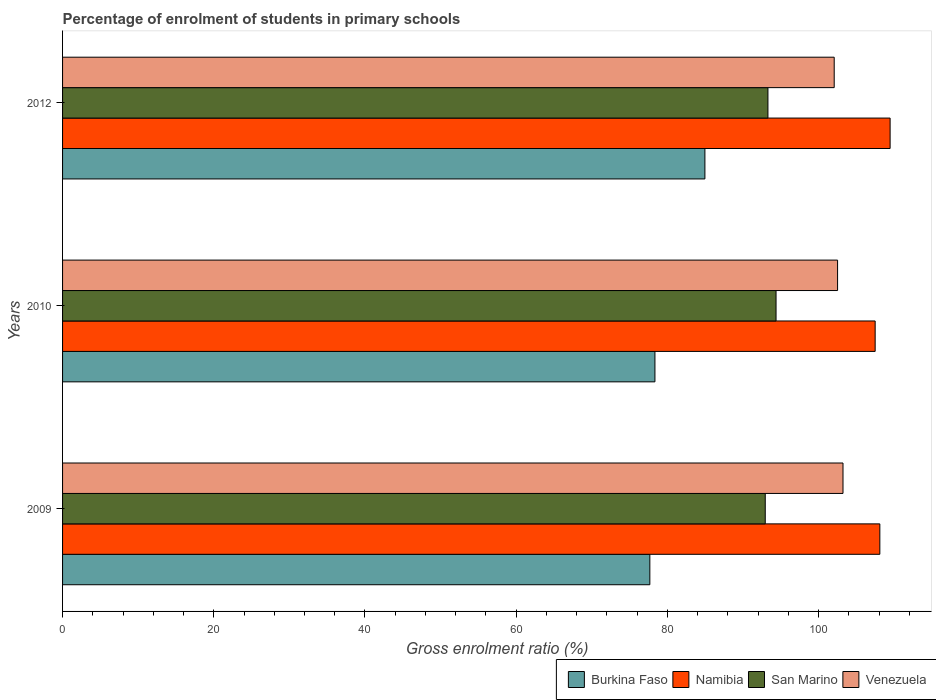How many different coloured bars are there?
Provide a succinct answer. 4. Are the number of bars per tick equal to the number of legend labels?
Give a very brief answer. Yes. What is the label of the 3rd group of bars from the top?
Offer a very short reply. 2009. In how many cases, is the number of bars for a given year not equal to the number of legend labels?
Offer a very short reply. 0. What is the percentage of students enrolled in primary schools in Venezuela in 2012?
Keep it short and to the point. 102.07. Across all years, what is the maximum percentage of students enrolled in primary schools in Venezuela?
Ensure brevity in your answer.  103.23. Across all years, what is the minimum percentage of students enrolled in primary schools in Namibia?
Ensure brevity in your answer.  107.48. In which year was the percentage of students enrolled in primary schools in Namibia minimum?
Give a very brief answer. 2010. What is the total percentage of students enrolled in primary schools in Namibia in the graph?
Provide a succinct answer. 325.05. What is the difference between the percentage of students enrolled in primary schools in Namibia in 2009 and that in 2012?
Your answer should be very brief. -1.36. What is the difference between the percentage of students enrolled in primary schools in Venezuela in 2010 and the percentage of students enrolled in primary schools in Burkina Faso in 2009?
Offer a terse response. 24.83. What is the average percentage of students enrolled in primary schools in Burkina Faso per year?
Offer a terse response. 80.33. In the year 2012, what is the difference between the percentage of students enrolled in primary schools in Namibia and percentage of students enrolled in primary schools in Venezuela?
Provide a short and direct response. 7.39. What is the ratio of the percentage of students enrolled in primary schools in San Marino in 2009 to that in 2012?
Your response must be concise. 1. Is the difference between the percentage of students enrolled in primary schools in Namibia in 2010 and 2012 greater than the difference between the percentage of students enrolled in primary schools in Venezuela in 2010 and 2012?
Offer a terse response. No. What is the difference between the highest and the second highest percentage of students enrolled in primary schools in Venezuela?
Keep it short and to the point. 0.72. What is the difference between the highest and the lowest percentage of students enrolled in primary schools in Venezuela?
Ensure brevity in your answer.  1.16. Is the sum of the percentage of students enrolled in primary schools in Venezuela in 2010 and 2012 greater than the maximum percentage of students enrolled in primary schools in San Marino across all years?
Your response must be concise. Yes. What does the 1st bar from the top in 2010 represents?
Your response must be concise. Venezuela. What does the 1st bar from the bottom in 2009 represents?
Your answer should be compact. Burkina Faso. Is it the case that in every year, the sum of the percentage of students enrolled in primary schools in Namibia and percentage of students enrolled in primary schools in Burkina Faso is greater than the percentage of students enrolled in primary schools in San Marino?
Ensure brevity in your answer.  Yes. Are all the bars in the graph horizontal?
Keep it short and to the point. Yes. How many years are there in the graph?
Keep it short and to the point. 3. Are the values on the major ticks of X-axis written in scientific E-notation?
Give a very brief answer. No. Does the graph contain grids?
Make the answer very short. No. Where does the legend appear in the graph?
Your answer should be compact. Bottom right. How many legend labels are there?
Provide a short and direct response. 4. How are the legend labels stacked?
Provide a short and direct response. Horizontal. What is the title of the graph?
Provide a succinct answer. Percentage of enrolment of students in primary schools. Does "Swaziland" appear as one of the legend labels in the graph?
Ensure brevity in your answer.  No. What is the label or title of the X-axis?
Your response must be concise. Gross enrolment ratio (%). What is the label or title of the Y-axis?
Offer a terse response. Years. What is the Gross enrolment ratio (%) in Burkina Faso in 2009?
Offer a terse response. 77.68. What is the Gross enrolment ratio (%) in Namibia in 2009?
Your answer should be compact. 108.1. What is the Gross enrolment ratio (%) in San Marino in 2009?
Your answer should be compact. 92.95. What is the Gross enrolment ratio (%) in Venezuela in 2009?
Offer a very short reply. 103.23. What is the Gross enrolment ratio (%) in Burkina Faso in 2010?
Your response must be concise. 78.36. What is the Gross enrolment ratio (%) in Namibia in 2010?
Your answer should be very brief. 107.48. What is the Gross enrolment ratio (%) of San Marino in 2010?
Provide a short and direct response. 94.37. What is the Gross enrolment ratio (%) of Venezuela in 2010?
Offer a very short reply. 102.51. What is the Gross enrolment ratio (%) of Burkina Faso in 2012?
Your answer should be compact. 84.96. What is the Gross enrolment ratio (%) of Namibia in 2012?
Provide a succinct answer. 109.46. What is the Gross enrolment ratio (%) in San Marino in 2012?
Offer a terse response. 93.3. What is the Gross enrolment ratio (%) in Venezuela in 2012?
Provide a succinct answer. 102.07. Across all years, what is the maximum Gross enrolment ratio (%) in Burkina Faso?
Your response must be concise. 84.96. Across all years, what is the maximum Gross enrolment ratio (%) in Namibia?
Make the answer very short. 109.46. Across all years, what is the maximum Gross enrolment ratio (%) of San Marino?
Give a very brief answer. 94.37. Across all years, what is the maximum Gross enrolment ratio (%) of Venezuela?
Make the answer very short. 103.23. Across all years, what is the minimum Gross enrolment ratio (%) in Burkina Faso?
Give a very brief answer. 77.68. Across all years, what is the minimum Gross enrolment ratio (%) in Namibia?
Give a very brief answer. 107.48. Across all years, what is the minimum Gross enrolment ratio (%) in San Marino?
Keep it short and to the point. 92.95. Across all years, what is the minimum Gross enrolment ratio (%) in Venezuela?
Your answer should be very brief. 102.07. What is the total Gross enrolment ratio (%) of Burkina Faso in the graph?
Your answer should be compact. 241. What is the total Gross enrolment ratio (%) in Namibia in the graph?
Give a very brief answer. 325.05. What is the total Gross enrolment ratio (%) of San Marino in the graph?
Provide a succinct answer. 280.62. What is the total Gross enrolment ratio (%) in Venezuela in the graph?
Provide a short and direct response. 307.81. What is the difference between the Gross enrolment ratio (%) in Burkina Faso in 2009 and that in 2010?
Offer a very short reply. -0.67. What is the difference between the Gross enrolment ratio (%) in Namibia in 2009 and that in 2010?
Offer a very short reply. 0.62. What is the difference between the Gross enrolment ratio (%) of San Marino in 2009 and that in 2010?
Your answer should be compact. -1.43. What is the difference between the Gross enrolment ratio (%) of Venezuela in 2009 and that in 2010?
Your answer should be very brief. 0.72. What is the difference between the Gross enrolment ratio (%) in Burkina Faso in 2009 and that in 2012?
Offer a very short reply. -7.28. What is the difference between the Gross enrolment ratio (%) in Namibia in 2009 and that in 2012?
Your response must be concise. -1.36. What is the difference between the Gross enrolment ratio (%) in San Marino in 2009 and that in 2012?
Provide a short and direct response. -0.36. What is the difference between the Gross enrolment ratio (%) of Venezuela in 2009 and that in 2012?
Offer a very short reply. 1.16. What is the difference between the Gross enrolment ratio (%) of Burkina Faso in 2010 and that in 2012?
Ensure brevity in your answer.  -6.61. What is the difference between the Gross enrolment ratio (%) of Namibia in 2010 and that in 2012?
Offer a very short reply. -1.98. What is the difference between the Gross enrolment ratio (%) of San Marino in 2010 and that in 2012?
Give a very brief answer. 1.07. What is the difference between the Gross enrolment ratio (%) in Venezuela in 2010 and that in 2012?
Keep it short and to the point. 0.45. What is the difference between the Gross enrolment ratio (%) in Burkina Faso in 2009 and the Gross enrolment ratio (%) in Namibia in 2010?
Your answer should be compact. -29.8. What is the difference between the Gross enrolment ratio (%) of Burkina Faso in 2009 and the Gross enrolment ratio (%) of San Marino in 2010?
Offer a very short reply. -16.69. What is the difference between the Gross enrolment ratio (%) of Burkina Faso in 2009 and the Gross enrolment ratio (%) of Venezuela in 2010?
Your answer should be compact. -24.83. What is the difference between the Gross enrolment ratio (%) of Namibia in 2009 and the Gross enrolment ratio (%) of San Marino in 2010?
Keep it short and to the point. 13.73. What is the difference between the Gross enrolment ratio (%) of Namibia in 2009 and the Gross enrolment ratio (%) of Venezuela in 2010?
Provide a succinct answer. 5.59. What is the difference between the Gross enrolment ratio (%) of San Marino in 2009 and the Gross enrolment ratio (%) of Venezuela in 2010?
Provide a short and direct response. -9.57. What is the difference between the Gross enrolment ratio (%) in Burkina Faso in 2009 and the Gross enrolment ratio (%) in Namibia in 2012?
Your answer should be very brief. -31.78. What is the difference between the Gross enrolment ratio (%) in Burkina Faso in 2009 and the Gross enrolment ratio (%) in San Marino in 2012?
Your answer should be compact. -15.62. What is the difference between the Gross enrolment ratio (%) in Burkina Faso in 2009 and the Gross enrolment ratio (%) in Venezuela in 2012?
Make the answer very short. -24.39. What is the difference between the Gross enrolment ratio (%) of Namibia in 2009 and the Gross enrolment ratio (%) of San Marino in 2012?
Your answer should be very brief. 14.8. What is the difference between the Gross enrolment ratio (%) of Namibia in 2009 and the Gross enrolment ratio (%) of Venezuela in 2012?
Offer a terse response. 6.04. What is the difference between the Gross enrolment ratio (%) in San Marino in 2009 and the Gross enrolment ratio (%) in Venezuela in 2012?
Keep it short and to the point. -9.12. What is the difference between the Gross enrolment ratio (%) in Burkina Faso in 2010 and the Gross enrolment ratio (%) in Namibia in 2012?
Offer a very short reply. -31.11. What is the difference between the Gross enrolment ratio (%) of Burkina Faso in 2010 and the Gross enrolment ratio (%) of San Marino in 2012?
Offer a terse response. -14.95. What is the difference between the Gross enrolment ratio (%) in Burkina Faso in 2010 and the Gross enrolment ratio (%) in Venezuela in 2012?
Give a very brief answer. -23.71. What is the difference between the Gross enrolment ratio (%) in Namibia in 2010 and the Gross enrolment ratio (%) in San Marino in 2012?
Your response must be concise. 14.18. What is the difference between the Gross enrolment ratio (%) of Namibia in 2010 and the Gross enrolment ratio (%) of Venezuela in 2012?
Provide a short and direct response. 5.42. What is the difference between the Gross enrolment ratio (%) in San Marino in 2010 and the Gross enrolment ratio (%) in Venezuela in 2012?
Provide a succinct answer. -7.69. What is the average Gross enrolment ratio (%) of Burkina Faso per year?
Your response must be concise. 80.33. What is the average Gross enrolment ratio (%) of Namibia per year?
Make the answer very short. 108.35. What is the average Gross enrolment ratio (%) in San Marino per year?
Offer a very short reply. 93.54. What is the average Gross enrolment ratio (%) in Venezuela per year?
Provide a succinct answer. 102.6. In the year 2009, what is the difference between the Gross enrolment ratio (%) of Burkina Faso and Gross enrolment ratio (%) of Namibia?
Make the answer very short. -30.42. In the year 2009, what is the difference between the Gross enrolment ratio (%) in Burkina Faso and Gross enrolment ratio (%) in San Marino?
Provide a succinct answer. -15.27. In the year 2009, what is the difference between the Gross enrolment ratio (%) of Burkina Faso and Gross enrolment ratio (%) of Venezuela?
Ensure brevity in your answer.  -25.55. In the year 2009, what is the difference between the Gross enrolment ratio (%) of Namibia and Gross enrolment ratio (%) of San Marino?
Provide a short and direct response. 15.16. In the year 2009, what is the difference between the Gross enrolment ratio (%) of Namibia and Gross enrolment ratio (%) of Venezuela?
Offer a very short reply. 4.87. In the year 2009, what is the difference between the Gross enrolment ratio (%) in San Marino and Gross enrolment ratio (%) in Venezuela?
Give a very brief answer. -10.29. In the year 2010, what is the difference between the Gross enrolment ratio (%) in Burkina Faso and Gross enrolment ratio (%) in Namibia?
Provide a short and direct response. -29.13. In the year 2010, what is the difference between the Gross enrolment ratio (%) of Burkina Faso and Gross enrolment ratio (%) of San Marino?
Provide a succinct answer. -16.02. In the year 2010, what is the difference between the Gross enrolment ratio (%) in Burkina Faso and Gross enrolment ratio (%) in Venezuela?
Keep it short and to the point. -24.16. In the year 2010, what is the difference between the Gross enrolment ratio (%) in Namibia and Gross enrolment ratio (%) in San Marino?
Provide a succinct answer. 13.11. In the year 2010, what is the difference between the Gross enrolment ratio (%) in Namibia and Gross enrolment ratio (%) in Venezuela?
Provide a succinct answer. 4.97. In the year 2010, what is the difference between the Gross enrolment ratio (%) of San Marino and Gross enrolment ratio (%) of Venezuela?
Give a very brief answer. -8.14. In the year 2012, what is the difference between the Gross enrolment ratio (%) in Burkina Faso and Gross enrolment ratio (%) in Namibia?
Keep it short and to the point. -24.5. In the year 2012, what is the difference between the Gross enrolment ratio (%) in Burkina Faso and Gross enrolment ratio (%) in San Marino?
Offer a very short reply. -8.34. In the year 2012, what is the difference between the Gross enrolment ratio (%) of Burkina Faso and Gross enrolment ratio (%) of Venezuela?
Keep it short and to the point. -17.1. In the year 2012, what is the difference between the Gross enrolment ratio (%) of Namibia and Gross enrolment ratio (%) of San Marino?
Give a very brief answer. 16.16. In the year 2012, what is the difference between the Gross enrolment ratio (%) in Namibia and Gross enrolment ratio (%) in Venezuela?
Offer a very short reply. 7.39. In the year 2012, what is the difference between the Gross enrolment ratio (%) in San Marino and Gross enrolment ratio (%) in Venezuela?
Give a very brief answer. -8.77. What is the ratio of the Gross enrolment ratio (%) of Burkina Faso in 2009 to that in 2010?
Provide a succinct answer. 0.99. What is the ratio of the Gross enrolment ratio (%) of Namibia in 2009 to that in 2010?
Your answer should be compact. 1.01. What is the ratio of the Gross enrolment ratio (%) in San Marino in 2009 to that in 2010?
Provide a short and direct response. 0.98. What is the ratio of the Gross enrolment ratio (%) in Burkina Faso in 2009 to that in 2012?
Your answer should be compact. 0.91. What is the ratio of the Gross enrolment ratio (%) of Namibia in 2009 to that in 2012?
Your response must be concise. 0.99. What is the ratio of the Gross enrolment ratio (%) of Venezuela in 2009 to that in 2012?
Offer a very short reply. 1.01. What is the ratio of the Gross enrolment ratio (%) in Burkina Faso in 2010 to that in 2012?
Give a very brief answer. 0.92. What is the ratio of the Gross enrolment ratio (%) in Namibia in 2010 to that in 2012?
Your response must be concise. 0.98. What is the ratio of the Gross enrolment ratio (%) of San Marino in 2010 to that in 2012?
Offer a very short reply. 1.01. What is the difference between the highest and the second highest Gross enrolment ratio (%) in Burkina Faso?
Offer a very short reply. 6.61. What is the difference between the highest and the second highest Gross enrolment ratio (%) in Namibia?
Provide a short and direct response. 1.36. What is the difference between the highest and the second highest Gross enrolment ratio (%) in San Marino?
Make the answer very short. 1.07. What is the difference between the highest and the second highest Gross enrolment ratio (%) in Venezuela?
Keep it short and to the point. 0.72. What is the difference between the highest and the lowest Gross enrolment ratio (%) in Burkina Faso?
Make the answer very short. 7.28. What is the difference between the highest and the lowest Gross enrolment ratio (%) of Namibia?
Provide a short and direct response. 1.98. What is the difference between the highest and the lowest Gross enrolment ratio (%) in San Marino?
Your response must be concise. 1.43. What is the difference between the highest and the lowest Gross enrolment ratio (%) in Venezuela?
Your response must be concise. 1.16. 